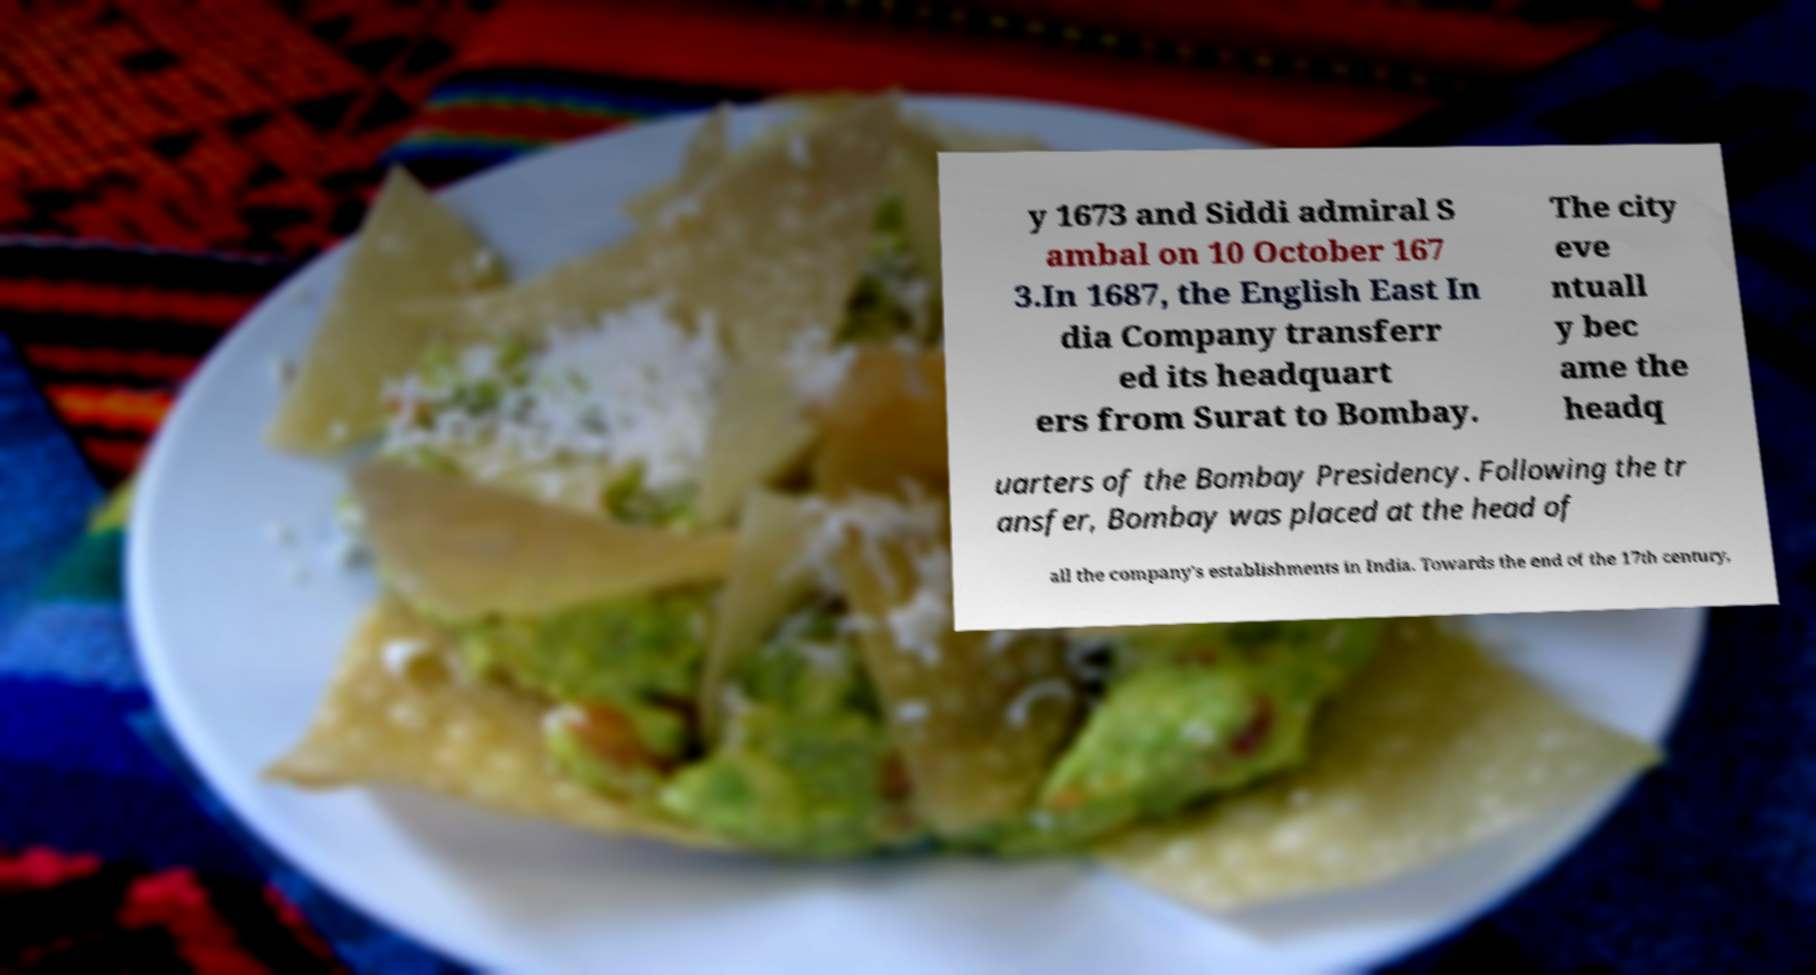Can you accurately transcribe the text from the provided image for me? y 1673 and Siddi admiral S ambal on 10 October 167 3.In 1687, the English East In dia Company transferr ed its headquart ers from Surat to Bombay. The city eve ntuall y bec ame the headq uarters of the Bombay Presidency. Following the tr ansfer, Bombay was placed at the head of all the company's establishments in India. Towards the end of the 17th century, 